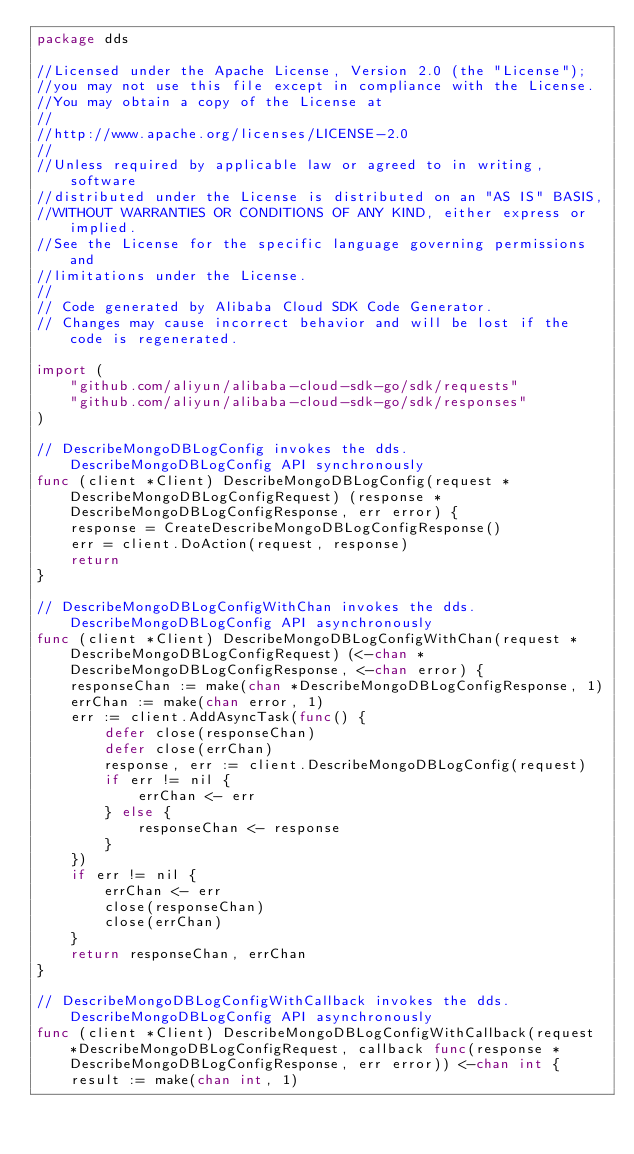<code> <loc_0><loc_0><loc_500><loc_500><_Go_>package dds

//Licensed under the Apache License, Version 2.0 (the "License");
//you may not use this file except in compliance with the License.
//You may obtain a copy of the License at
//
//http://www.apache.org/licenses/LICENSE-2.0
//
//Unless required by applicable law or agreed to in writing, software
//distributed under the License is distributed on an "AS IS" BASIS,
//WITHOUT WARRANTIES OR CONDITIONS OF ANY KIND, either express or implied.
//See the License for the specific language governing permissions and
//limitations under the License.
//
// Code generated by Alibaba Cloud SDK Code Generator.
// Changes may cause incorrect behavior and will be lost if the code is regenerated.

import (
	"github.com/aliyun/alibaba-cloud-sdk-go/sdk/requests"
	"github.com/aliyun/alibaba-cloud-sdk-go/sdk/responses"
)

// DescribeMongoDBLogConfig invokes the dds.DescribeMongoDBLogConfig API synchronously
func (client *Client) DescribeMongoDBLogConfig(request *DescribeMongoDBLogConfigRequest) (response *DescribeMongoDBLogConfigResponse, err error) {
	response = CreateDescribeMongoDBLogConfigResponse()
	err = client.DoAction(request, response)
	return
}

// DescribeMongoDBLogConfigWithChan invokes the dds.DescribeMongoDBLogConfig API asynchronously
func (client *Client) DescribeMongoDBLogConfigWithChan(request *DescribeMongoDBLogConfigRequest) (<-chan *DescribeMongoDBLogConfigResponse, <-chan error) {
	responseChan := make(chan *DescribeMongoDBLogConfigResponse, 1)
	errChan := make(chan error, 1)
	err := client.AddAsyncTask(func() {
		defer close(responseChan)
		defer close(errChan)
		response, err := client.DescribeMongoDBLogConfig(request)
		if err != nil {
			errChan <- err
		} else {
			responseChan <- response
		}
	})
	if err != nil {
		errChan <- err
		close(responseChan)
		close(errChan)
	}
	return responseChan, errChan
}

// DescribeMongoDBLogConfigWithCallback invokes the dds.DescribeMongoDBLogConfig API asynchronously
func (client *Client) DescribeMongoDBLogConfigWithCallback(request *DescribeMongoDBLogConfigRequest, callback func(response *DescribeMongoDBLogConfigResponse, err error)) <-chan int {
	result := make(chan int, 1)</code> 